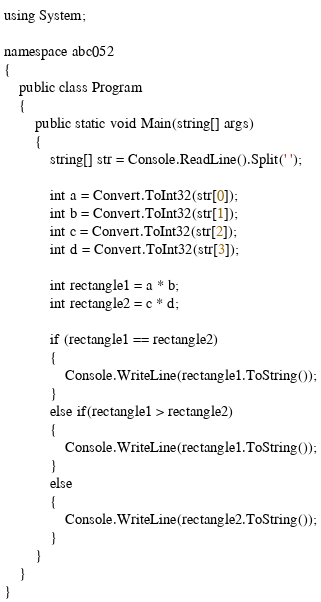Convert code to text. <code><loc_0><loc_0><loc_500><loc_500><_C#_>using System;
 
namespace abc052
{
    public class Program
    {
        public static void Main(string[] args)
        {
            string[] str = Console.ReadLine().Split(' ');
 
            int a = Convert.ToInt32(str[0]);
            int b = Convert.ToInt32(str[1]);
            int c = Convert.ToInt32(str[2]);
            int d = Convert.ToInt32(str[3]);
 
            int rectangle1 = a * b;
            int rectangle2 = c * d;
 
            if (rectangle1 == rectangle2)
            {
                Console.WriteLine(rectangle1.ToString());
            }
            else if(rectangle1 > rectangle2)
            {
                Console.WriteLine(rectangle1.ToString());
            }
            else
            {
                Console.WriteLine(rectangle2.ToString());
            }
        }
    }
}</code> 